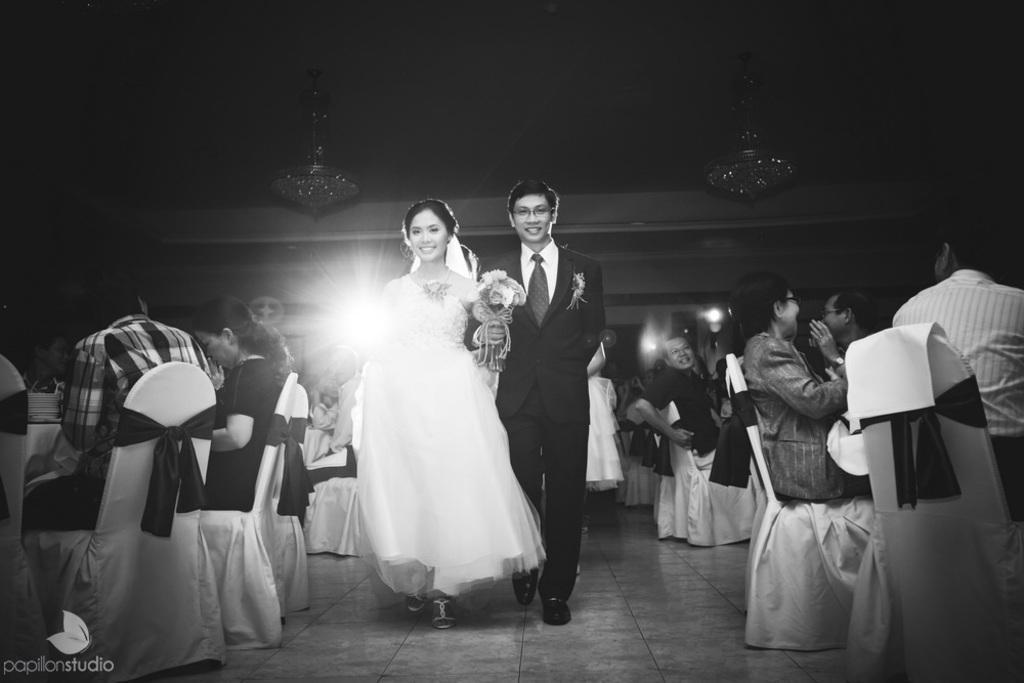Describe this image in one or two sentences. Here we can see a woman and a man walking on the floor and they are smiling. They are holding a bouquet with their hands. Here we can see group of people sitting on the chairs. There are ceiling lights. 